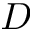Convert formula to latex. <formula><loc_0><loc_0><loc_500><loc_500>D</formula> 